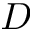Convert formula to latex. <formula><loc_0><loc_0><loc_500><loc_500>D</formula> 